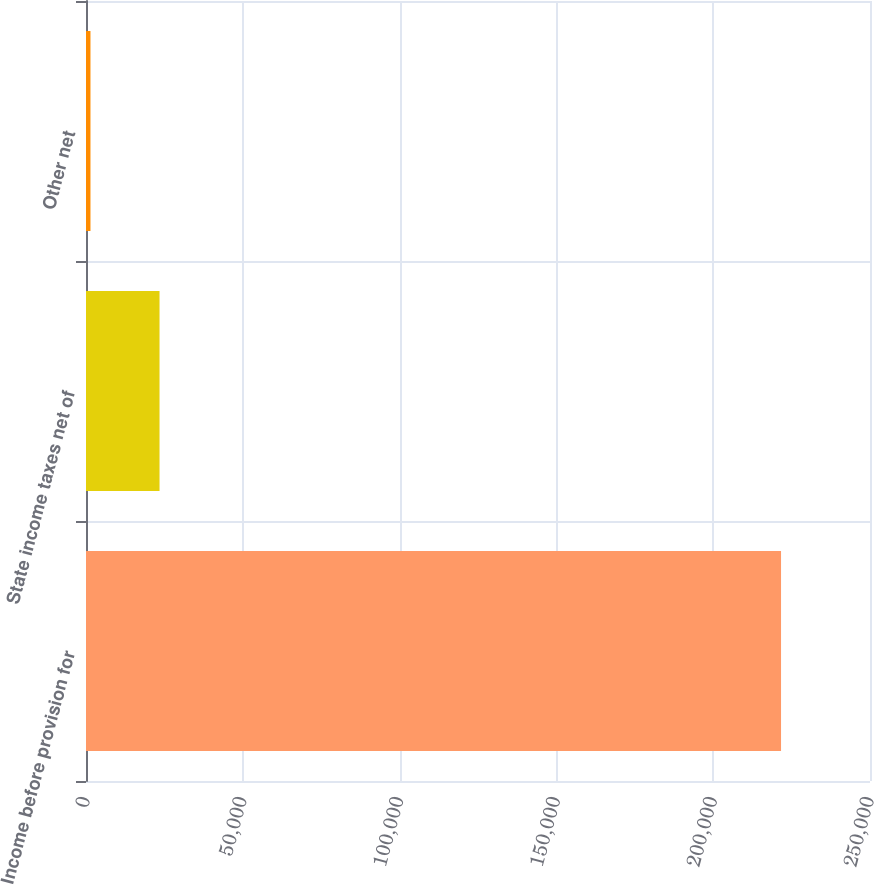Convert chart. <chart><loc_0><loc_0><loc_500><loc_500><bar_chart><fcel>Income before provision for<fcel>State income taxes net of<fcel>Other net<nl><fcel>221632<fcel>23446.6<fcel>1426<nl></chart> 